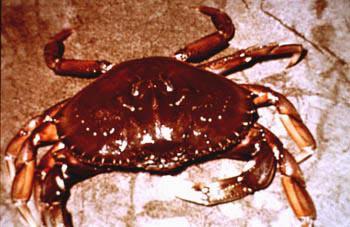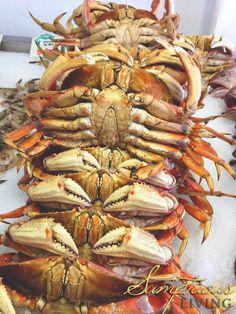The first image is the image on the left, the second image is the image on the right. For the images displayed, is the sentence "There are more than three crabs." factually correct? Answer yes or no. Yes. 